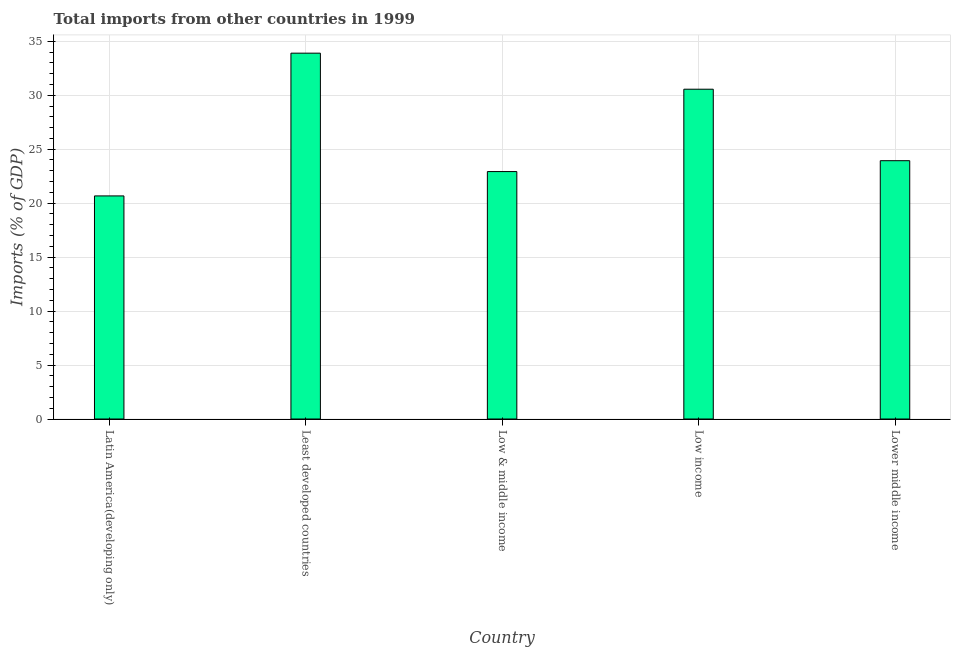Does the graph contain any zero values?
Keep it short and to the point. No. What is the title of the graph?
Make the answer very short. Total imports from other countries in 1999. What is the label or title of the Y-axis?
Provide a short and direct response. Imports (% of GDP). What is the total imports in Latin America(developing only)?
Offer a very short reply. 20.67. Across all countries, what is the maximum total imports?
Provide a succinct answer. 33.9. Across all countries, what is the minimum total imports?
Offer a very short reply. 20.67. In which country was the total imports maximum?
Your answer should be very brief. Least developed countries. In which country was the total imports minimum?
Ensure brevity in your answer.  Latin America(developing only). What is the sum of the total imports?
Keep it short and to the point. 131.99. What is the difference between the total imports in Latin America(developing only) and Low & middle income?
Provide a succinct answer. -2.26. What is the average total imports per country?
Provide a short and direct response. 26.4. What is the median total imports?
Offer a terse response. 23.94. In how many countries, is the total imports greater than 13 %?
Make the answer very short. 5. What is the ratio of the total imports in Least developed countries to that in Low income?
Ensure brevity in your answer.  1.11. Is the total imports in Latin America(developing only) less than that in Least developed countries?
Your answer should be very brief. Yes. What is the difference between the highest and the second highest total imports?
Provide a succinct answer. 3.34. What is the difference between the highest and the lowest total imports?
Keep it short and to the point. 13.23. How many bars are there?
Your answer should be compact. 5. Are all the bars in the graph horizontal?
Make the answer very short. No. How many countries are there in the graph?
Give a very brief answer. 5. What is the difference between two consecutive major ticks on the Y-axis?
Give a very brief answer. 5. What is the Imports (% of GDP) in Latin America(developing only)?
Provide a succinct answer. 20.67. What is the Imports (% of GDP) of Least developed countries?
Offer a very short reply. 33.9. What is the Imports (% of GDP) in Low & middle income?
Give a very brief answer. 22.93. What is the Imports (% of GDP) in Low income?
Make the answer very short. 30.56. What is the Imports (% of GDP) in Lower middle income?
Keep it short and to the point. 23.94. What is the difference between the Imports (% of GDP) in Latin America(developing only) and Least developed countries?
Make the answer very short. -13.23. What is the difference between the Imports (% of GDP) in Latin America(developing only) and Low & middle income?
Your answer should be very brief. -2.26. What is the difference between the Imports (% of GDP) in Latin America(developing only) and Low income?
Ensure brevity in your answer.  -9.89. What is the difference between the Imports (% of GDP) in Latin America(developing only) and Lower middle income?
Ensure brevity in your answer.  -3.26. What is the difference between the Imports (% of GDP) in Least developed countries and Low & middle income?
Your answer should be very brief. 10.97. What is the difference between the Imports (% of GDP) in Least developed countries and Low income?
Your answer should be compact. 3.34. What is the difference between the Imports (% of GDP) in Least developed countries and Lower middle income?
Your response must be concise. 9.96. What is the difference between the Imports (% of GDP) in Low & middle income and Low income?
Keep it short and to the point. -7.63. What is the difference between the Imports (% of GDP) in Low & middle income and Lower middle income?
Your answer should be very brief. -1.01. What is the difference between the Imports (% of GDP) in Low income and Lower middle income?
Provide a succinct answer. 6.62. What is the ratio of the Imports (% of GDP) in Latin America(developing only) to that in Least developed countries?
Keep it short and to the point. 0.61. What is the ratio of the Imports (% of GDP) in Latin America(developing only) to that in Low & middle income?
Your answer should be very brief. 0.9. What is the ratio of the Imports (% of GDP) in Latin America(developing only) to that in Low income?
Your response must be concise. 0.68. What is the ratio of the Imports (% of GDP) in Latin America(developing only) to that in Lower middle income?
Ensure brevity in your answer.  0.86. What is the ratio of the Imports (% of GDP) in Least developed countries to that in Low & middle income?
Keep it short and to the point. 1.48. What is the ratio of the Imports (% of GDP) in Least developed countries to that in Low income?
Your answer should be very brief. 1.11. What is the ratio of the Imports (% of GDP) in Least developed countries to that in Lower middle income?
Keep it short and to the point. 1.42. What is the ratio of the Imports (% of GDP) in Low & middle income to that in Lower middle income?
Your answer should be very brief. 0.96. What is the ratio of the Imports (% of GDP) in Low income to that in Lower middle income?
Provide a short and direct response. 1.28. 